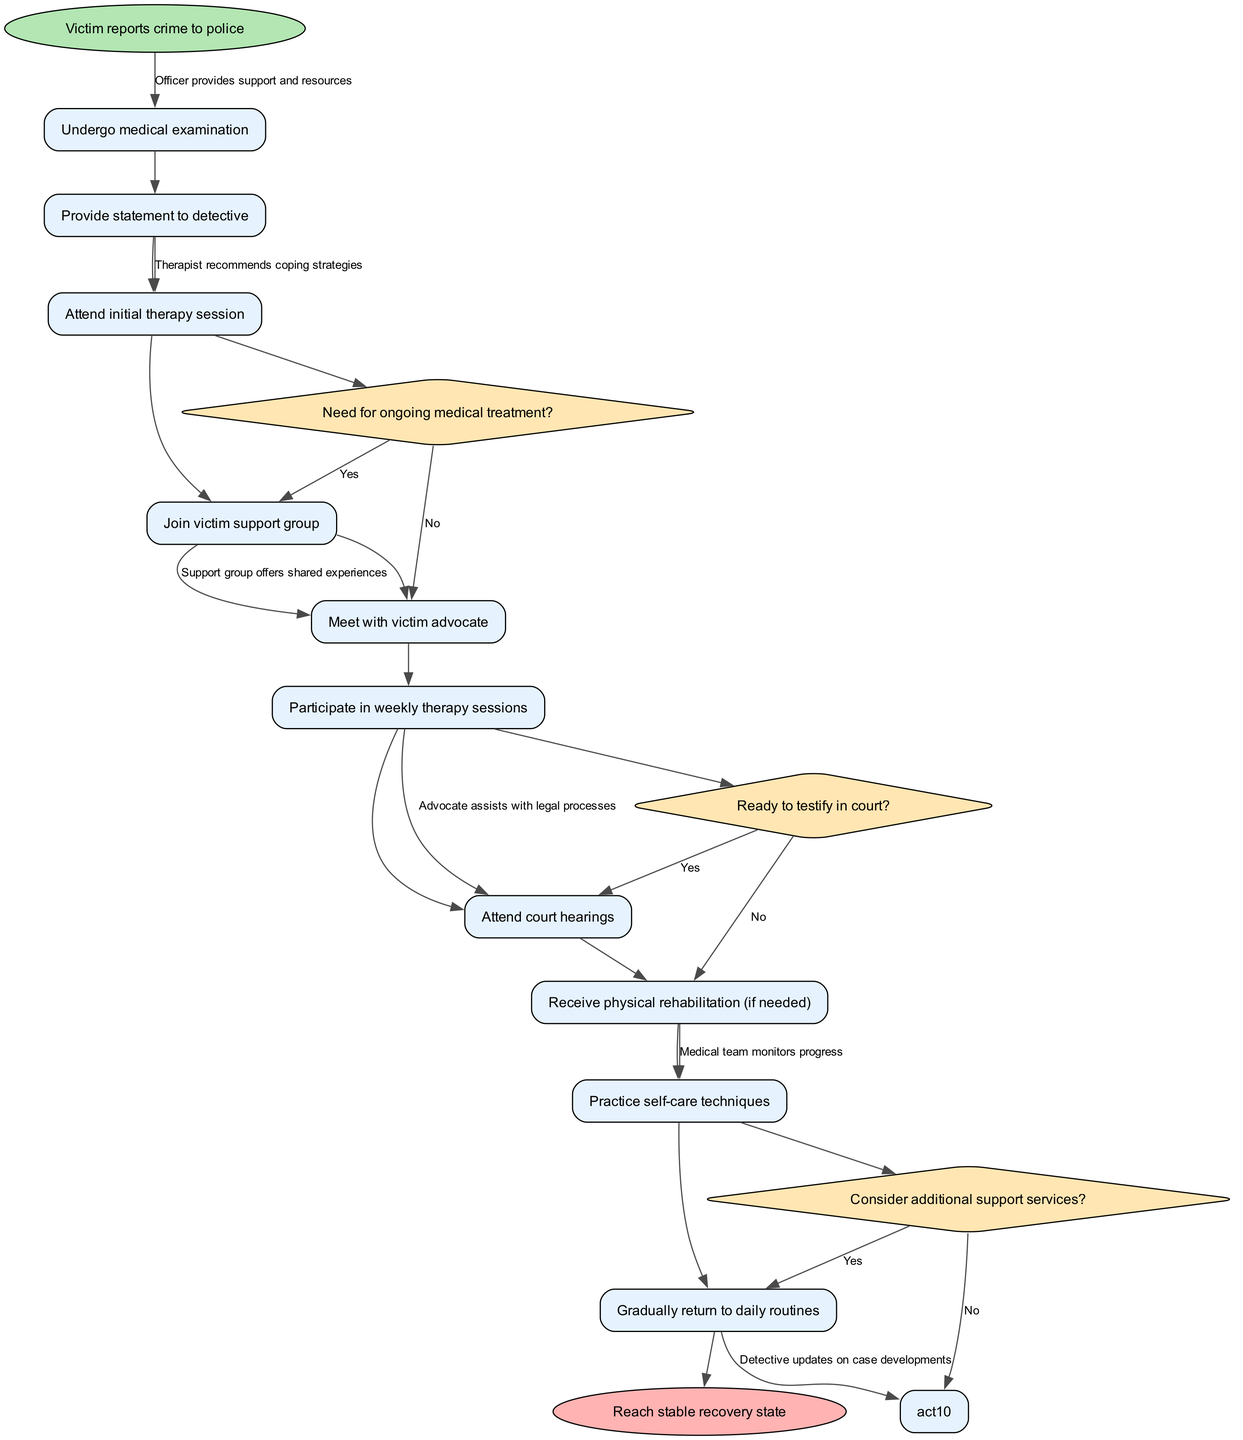What is the initial activity in the diagram? The initial activity is represented by the first activity node connected to the start node. The diagram clearly states "Victim reports crime to police" as the first activity.
Answer: Victim reports crime to police How many decision nodes are present in the diagram? By counting the diamond shapes in the diagram that represent decision nodes, we find that there are three unique decision nodes present in the activity flow.
Answer: 3 What follows after the "Attend initial therapy session"? The activity that directly follows "Attend initial therapy session" is determined by the edge connecting these two activities. The next activity is "Join victim support group".
Answer: Join victim support group What decision is made after the "Participate in weekly therapy sessions"? The decision which follows "Participate in weekly therapy sessions" can be identified from the connecting edge. It presents the question, "Need for ongoing medical treatment?"
Answer: Need for ongoing medical treatment? Which activity involves returning to daily life? The activity that concerns returning to daily routines is located towards the end of the diagram and is directly labeled as "Gradually return to daily routines".
Answer: Gradually return to daily routines What is the end state of the rehabilitation process? The end state is indicated by the oval shape labeled at the end of the diagram, which describes the final outcome of the process. It states "Reach stable recovery state".
Answer: Reach stable recovery state Which activity occurs before "Attend court hearings"? To identify the activity that precedes "Attend court hearings", we look at the flow of activities. The activity just before it is "Join victim support group".
Answer: Join victim support group How many activities are there in total? Counting all the rectangular nodes representing activities in the diagram, there are ten distinct activities listed throughout the rehabilitation process flow.
Answer: 10 